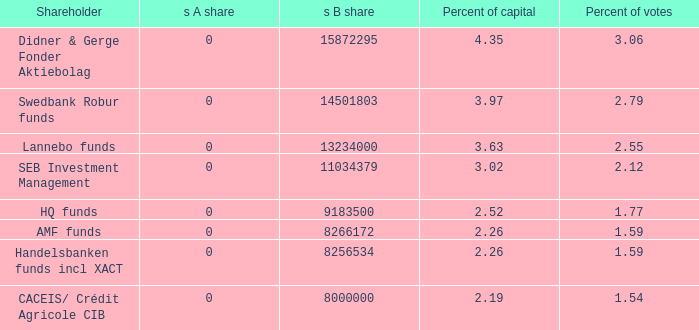What is the s b share for the equity holder possessing 11034379.0. 